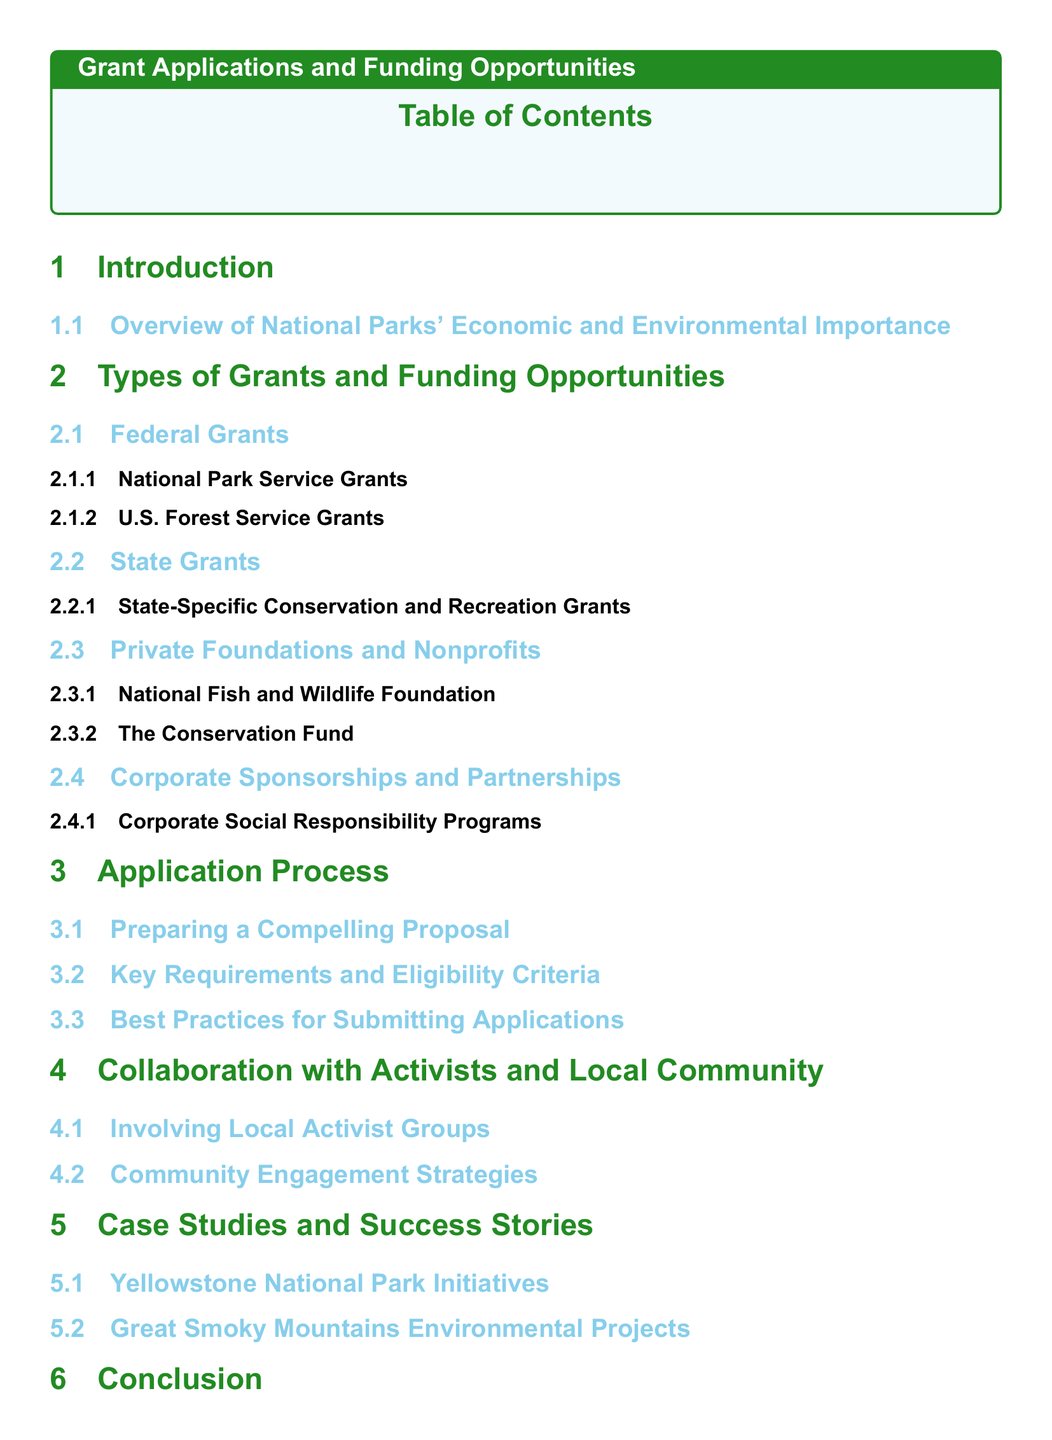What section discusses federal grants? Federal grants are detailed under the section titled "Types of Grants and Funding Opportunities."
Answer: Federal Grants What is the subtitle of the Grant Applications and Funding Opportunities section? The subtitle describes the focus on available grants and partnerships supporting projects in national parks.
Answer: A comprehensive list of available grants, funding sources, and partnerships that can support economic and environmental projects in national parks Which park is mentioned in the case studies? The case studies include initiatives from specific national parks, one of which is Yellowstone.
Answer: Yellowstone National Park What is emphasized as important for community engagement? The need to involve local activist groups is highlighted as essential for effective community engagement.
Answer: Involving Local Activist Groups What does the Conclusion section summarize? The Conclusion section summarizes the key points discussed throughout the document.
Answer: Summary of Key Points What type of resources are provided at the end of the document? The Additional Resources section includes useful links and contact information for further engagement.
Answer: Useful Links and Contact Information 